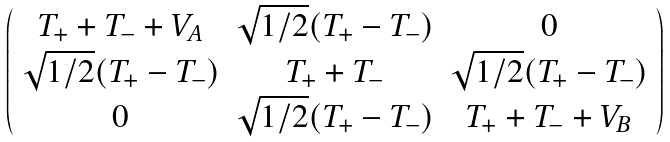<formula> <loc_0><loc_0><loc_500><loc_500>\left ( \begin{array} { c c c } T _ { + } + T _ { - } + V _ { A } & \sqrt { 1 / 2 } ( T _ { + } - T _ { - } ) & 0 \\ \sqrt { 1 / 2 } ( T _ { + } - T _ { - } ) & T _ { + } + T _ { - } & \sqrt { 1 / 2 } ( T _ { + } - T _ { - } ) \\ 0 & \sqrt { 1 / 2 } ( T _ { + } - T _ { - } ) & T _ { + } + T _ { - } + V _ { B } \end{array} \right )</formula> 